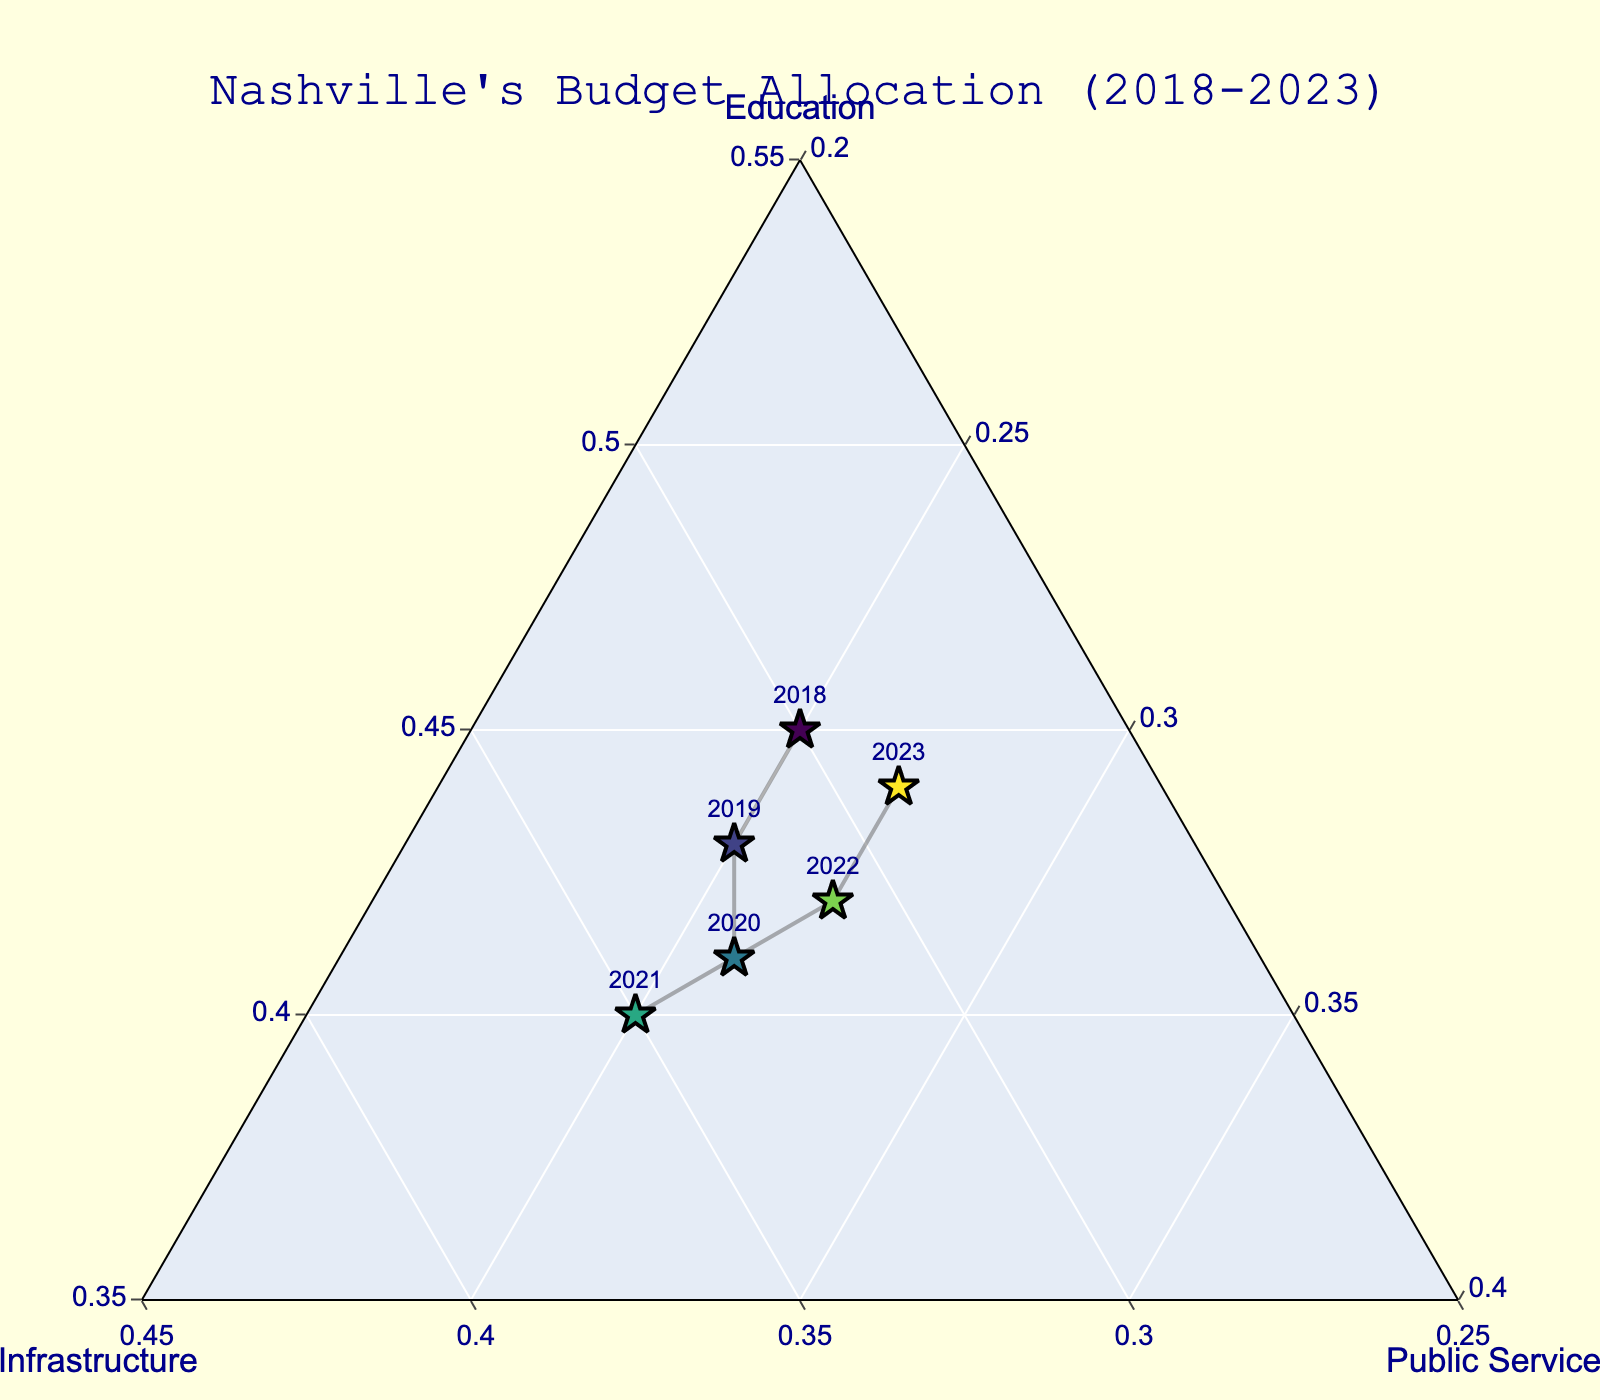What year had the highest percentage allocation to Infrastructure? The plot displays the relative allocation across Education, Infrastructure, and Public Services for each year and monitors shifts in allocations. Identify the year where the marker for Infrastructure is closest to the top-right axis label 'Infrastructure'.
Answer: 2021 During which year did Public Services receive its highest allocation? Look across the plot for the point that is closest to the 'Public Services' axis label and read off its corresponding year label.
Answer: 2022 and 2023 How does the proportion of the budget allocated towards Education between 2018 and 2023 change? By following the markers for Education from 2018 to 2023 along the plot, notice whether the distance from these markers to the 'Education' axis changes.
Answer: It slightly decreases, then increases Which year had the lowest relative allocation to Public Services? Find the data point that is furthest from the 'Public Services' axis and read off the corresponding year label.
Answer: 2018 What pattern do you observe in the allocation shifts toward Infrastructure? Observe the pattern and trend of markers aligned with the Infrastructure axis through the examined period and note any increases or decreases.
Answer: Allocation to Infrastructure generally increases until 2021 and then slightly decreases Compare the allocation of Education between 2018 and 2020. Which year has a higher allocation? Find the markers for 2018 and 2020 and compare their positions relative to the 'Education' axis. Look closer which year is nearer to the Education axis.
Answer: 2018 How does the budget allocation compare across Education, Infrastructure, and Public Services in 2019? For the year 2019, observe the position of its marker relative to all three axes and identify how the budget allocation compares.
Answer: Education > Infrastructure = Public Services Which year exhibits the most balanced allocation across all three sectors? Identify the point that appears most equidistant from all three triangle vertices and closer to the center of the ternary plot.
Answer: 2022 In which year did the budget for Education see its second highest allocation? After identifying the year with the highest allocation to Education, look at the next closest position to the 'Education' axis across the years.
Answer: 2023 